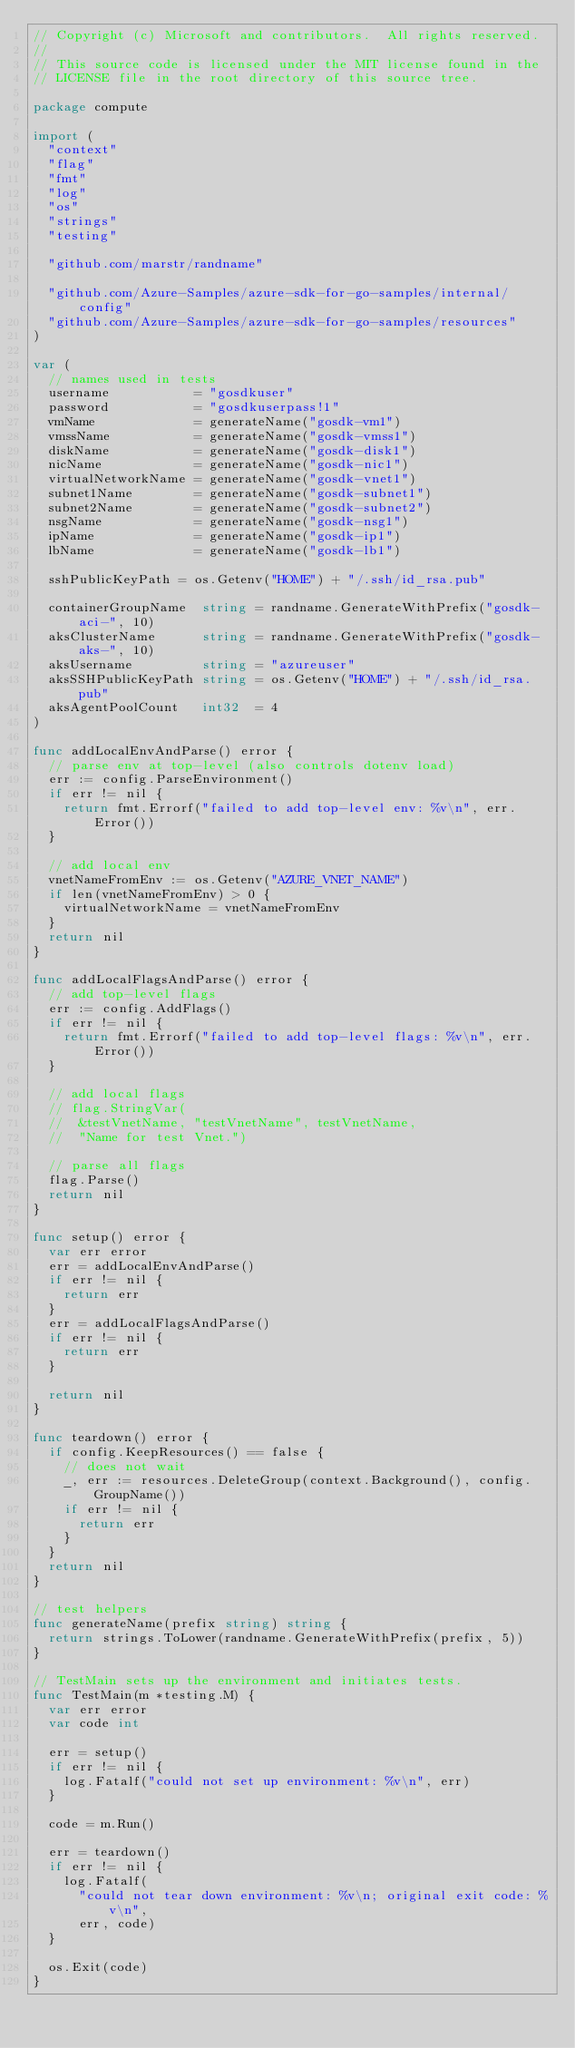Convert code to text. <code><loc_0><loc_0><loc_500><loc_500><_Go_>// Copyright (c) Microsoft and contributors.  All rights reserved.
//
// This source code is licensed under the MIT license found in the
// LICENSE file in the root directory of this source tree.

package compute

import (
	"context"
	"flag"
	"fmt"
	"log"
	"os"
	"strings"
	"testing"

	"github.com/marstr/randname"

	"github.com/Azure-Samples/azure-sdk-for-go-samples/internal/config"
	"github.com/Azure-Samples/azure-sdk-for-go-samples/resources"
)

var (
	// names used in tests
	username           = "gosdkuser"
	password           = "gosdkuserpass!1"
	vmName             = generateName("gosdk-vm1")
	vmssName           = generateName("gosdk-vmss1")
	diskName           = generateName("gosdk-disk1")
	nicName            = generateName("gosdk-nic1")
	virtualNetworkName = generateName("gosdk-vnet1")
	subnet1Name        = generateName("gosdk-subnet1")
	subnet2Name        = generateName("gosdk-subnet2")
	nsgName            = generateName("gosdk-nsg1")
	ipName             = generateName("gosdk-ip1")
	lbName             = generateName("gosdk-lb1")

	sshPublicKeyPath = os.Getenv("HOME") + "/.ssh/id_rsa.pub"

	containerGroupName  string = randname.GenerateWithPrefix("gosdk-aci-", 10)
	aksClusterName      string = randname.GenerateWithPrefix("gosdk-aks-", 10)
	aksUsername         string = "azureuser"
	aksSSHPublicKeyPath string = os.Getenv("HOME") + "/.ssh/id_rsa.pub"
	aksAgentPoolCount   int32  = 4
)

func addLocalEnvAndParse() error {
	// parse env at top-level (also controls dotenv load)
	err := config.ParseEnvironment()
	if err != nil {
		return fmt.Errorf("failed to add top-level env: %v\n", err.Error())
	}

	// add local env
	vnetNameFromEnv := os.Getenv("AZURE_VNET_NAME")
	if len(vnetNameFromEnv) > 0 {
		virtualNetworkName = vnetNameFromEnv
	}
	return nil
}

func addLocalFlagsAndParse() error {
	// add top-level flags
	err := config.AddFlags()
	if err != nil {
		return fmt.Errorf("failed to add top-level flags: %v\n", err.Error())
	}

	// add local flags
	// flag.StringVar(
	//	&testVnetName, "testVnetName", testVnetName,
	//	"Name for test Vnet.")

	// parse all flags
	flag.Parse()
	return nil
}

func setup() error {
	var err error
	err = addLocalEnvAndParse()
	if err != nil {
		return err
	}
	err = addLocalFlagsAndParse()
	if err != nil {
		return err
	}

	return nil
}

func teardown() error {
	if config.KeepResources() == false {
		// does not wait
		_, err := resources.DeleteGroup(context.Background(), config.GroupName())
		if err != nil {
			return err
		}
	}
	return nil
}

// test helpers
func generateName(prefix string) string {
	return strings.ToLower(randname.GenerateWithPrefix(prefix, 5))
}

// TestMain sets up the environment and initiates tests.
func TestMain(m *testing.M) {
	var err error
	var code int

	err = setup()
	if err != nil {
		log.Fatalf("could not set up environment: %v\n", err)
	}

	code = m.Run()

	err = teardown()
	if err != nil {
		log.Fatalf(
			"could not tear down environment: %v\n; original exit code: %v\n",
			err, code)
	}

	os.Exit(code)
}
</code> 